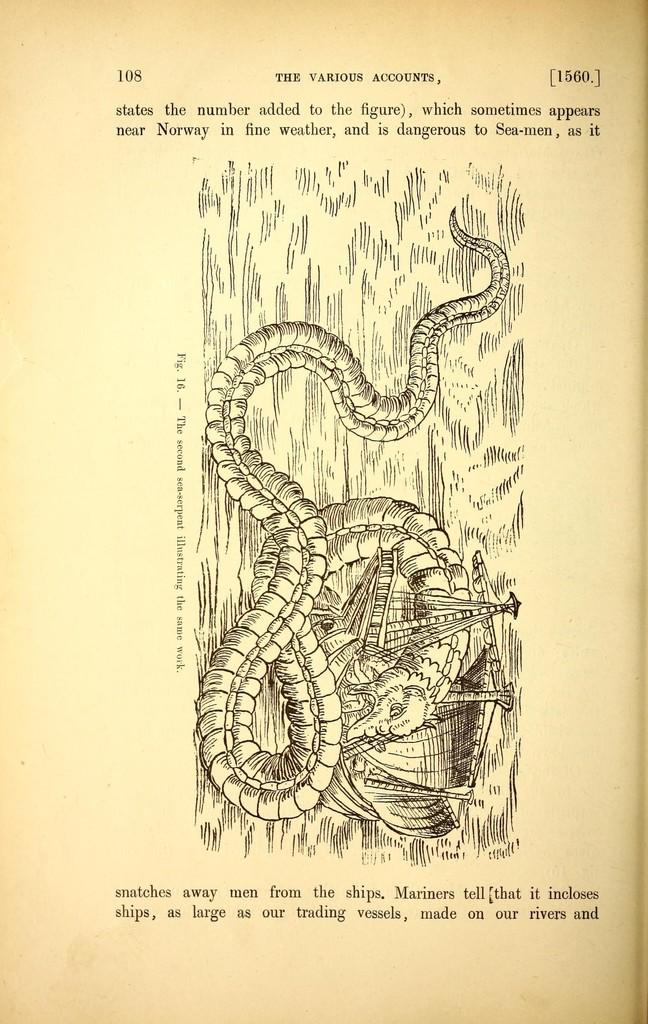What is the main subject of the sketch in the image? There is a sketch of an animal in the image. What else can be seen in the image besides the sketch of the animal? There are other things depicted in the image. Is there any text present in the image? Yes, there is writing on the image. How does the baby gain experience from the image? There is no baby present in the image, so it cannot gain experience from it. 